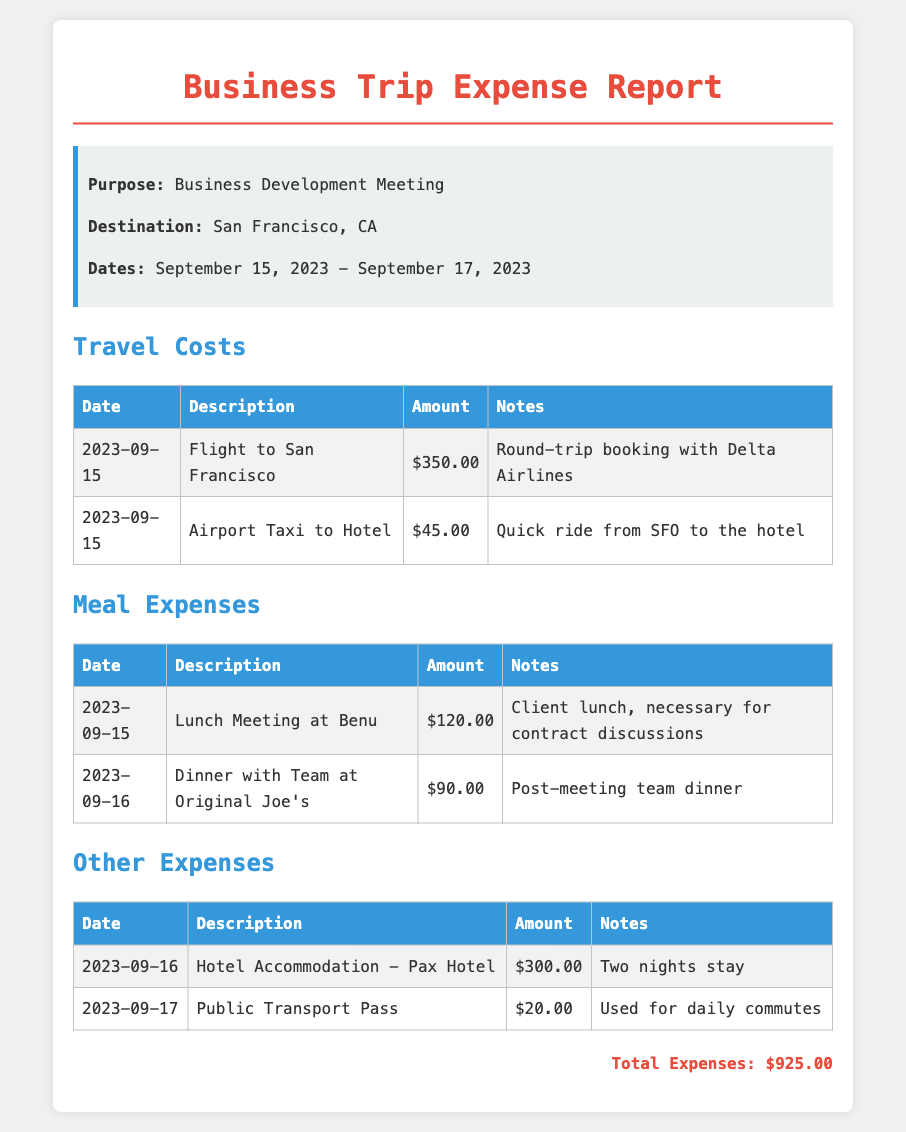What is the total amount for travel costs? The total amount for travel costs is the sum of all amounts listed under that category, which is $350.00 + $45.00 = $395.00.
Answer: $395.00 What was the purpose of the trip? The purpose of the trip is clearly stated in the document as "Business Development Meeting."
Answer: Business Development Meeting What was spent on the lunch meeting? The specific amount spent on the lunch meeting at Benu is detailed in the meal expenses table.
Answer: $120.00 Which transportation method was used to the hotel? The document specifies that an "Airport Taxi" was used to get to the hotel from the airport.
Answer: Airport Taxi How many nights was the hotel accommodation? The notes indicate that the hotel accommodation was for "Two nights stay."
Answer: Two nights What is the amount spent on the public transport pass? The document states the cost listed under 'Other Expenses' for the public transport pass.
Answer: $20.00 What is the date of the dinner with the team? The meal expenses table lists the date for the dinner with the team under its description.
Answer: 2023-09-16 What hotel was used for accommodation? The document specifically mentions "Pax Hotel" as the hotel for accommodation during the trip.
Answer: Pax Hotel What is the total expense for the trip? The total expense for the trip is summarized in the document as the sum of all individual expenses presented.
Answer: $925.00 